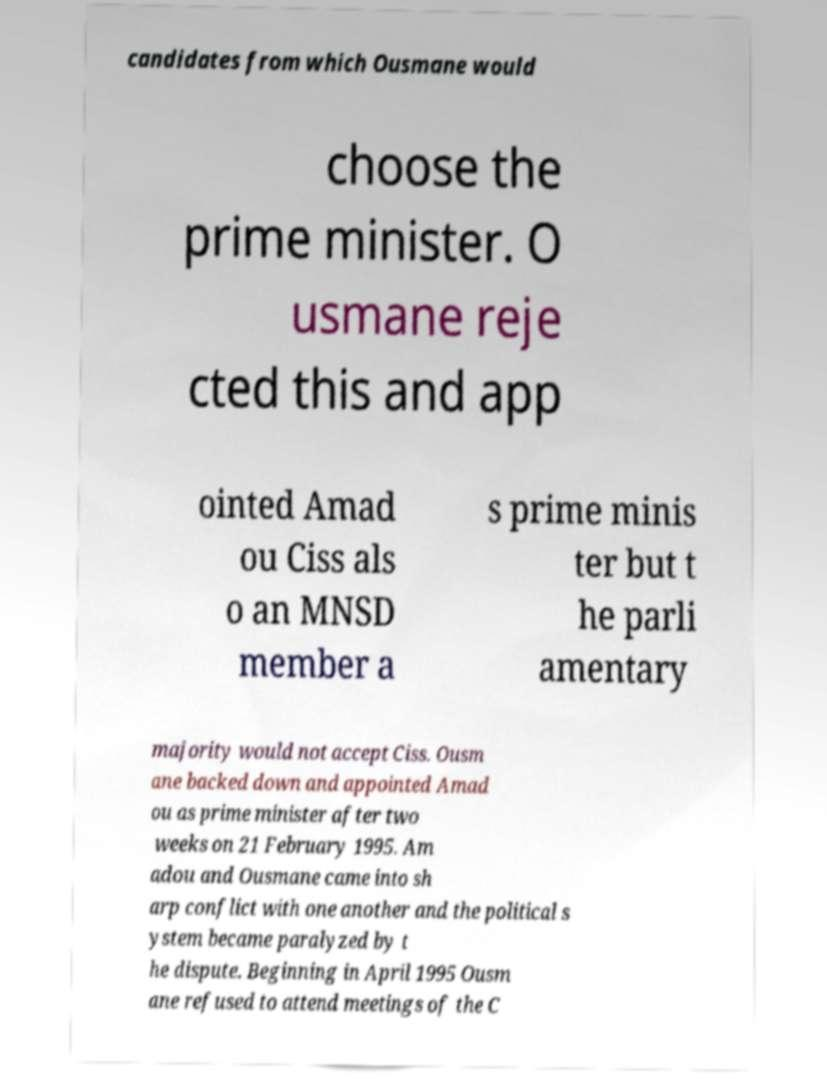Could you assist in decoding the text presented in this image and type it out clearly? candidates from which Ousmane would choose the prime minister. O usmane reje cted this and app ointed Amad ou Ciss als o an MNSD member a s prime minis ter but t he parli amentary majority would not accept Ciss. Ousm ane backed down and appointed Amad ou as prime minister after two weeks on 21 February 1995. Am adou and Ousmane came into sh arp conflict with one another and the political s ystem became paralyzed by t he dispute. Beginning in April 1995 Ousm ane refused to attend meetings of the C 